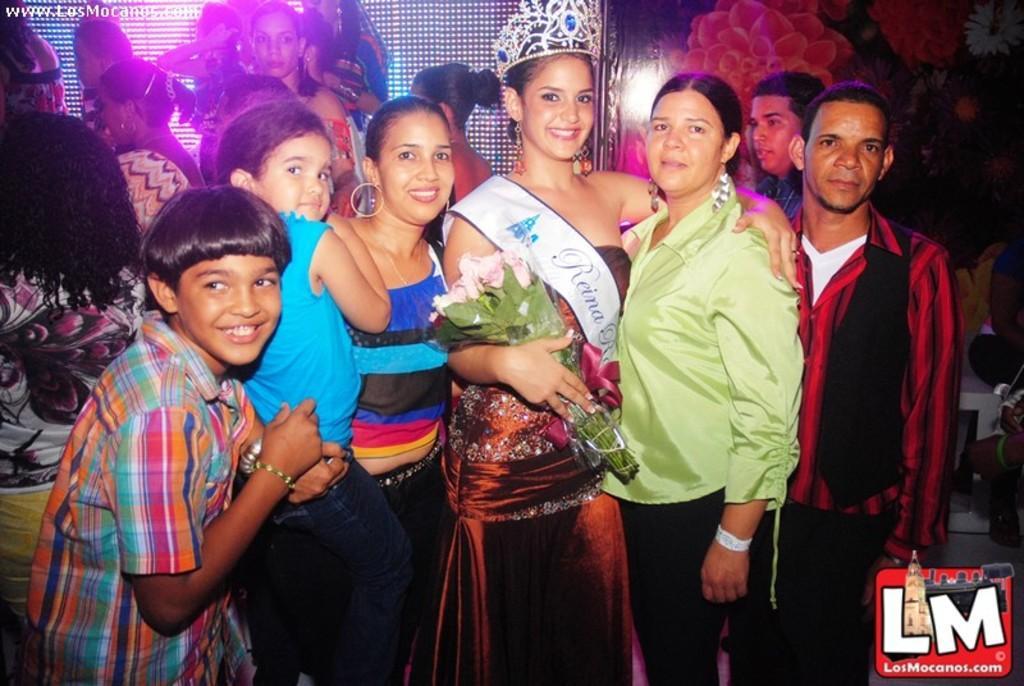In one or two sentences, can you explain what this image depicts? People are standing. A person is standing at the center wearing a crown and holding a flower bouquet. There are other people at the back. There is a floral background and there are lights. 